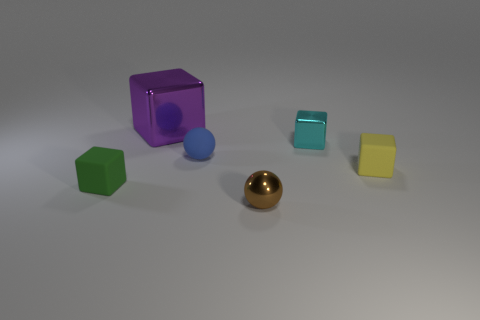The metallic ball that is the same size as the cyan cube is what color?
Offer a very short reply. Brown. Do the rubber thing that is right of the blue sphere and the blue matte thing have the same shape?
Provide a succinct answer. No. There is a object in front of the tiny cube that is on the left side of the big block behind the cyan metal block; what is its color?
Your answer should be compact. Brown. Are there any small gray matte blocks?
Make the answer very short. No. What number of other things are the same size as the cyan metallic thing?
Provide a short and direct response. 4. Is the color of the large shiny object the same as the ball behind the metallic sphere?
Make the answer very short. No. What number of things are either green rubber things or tiny cyan objects?
Your answer should be very brief. 2. Are there any other things of the same color as the big cube?
Offer a very short reply. No. Do the tiny green thing and the block behind the cyan cube have the same material?
Ensure brevity in your answer.  No. There is a tiny metallic object in front of the tiny rubber cube that is on the left side of the cyan metal block; what is its shape?
Keep it short and to the point. Sphere. 